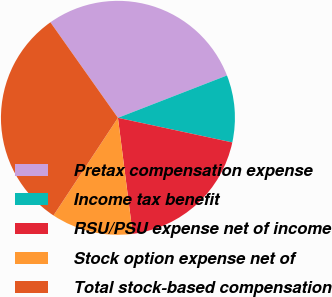<chart> <loc_0><loc_0><loc_500><loc_500><pie_chart><fcel>Pretax compensation expense<fcel>Income tax benefit<fcel>RSU/PSU expense net of income<fcel>Stock option expense net of<fcel>Total stock-based compensation<nl><fcel>28.89%<fcel>9.27%<fcel>19.61%<fcel>11.3%<fcel>30.92%<nl></chart> 